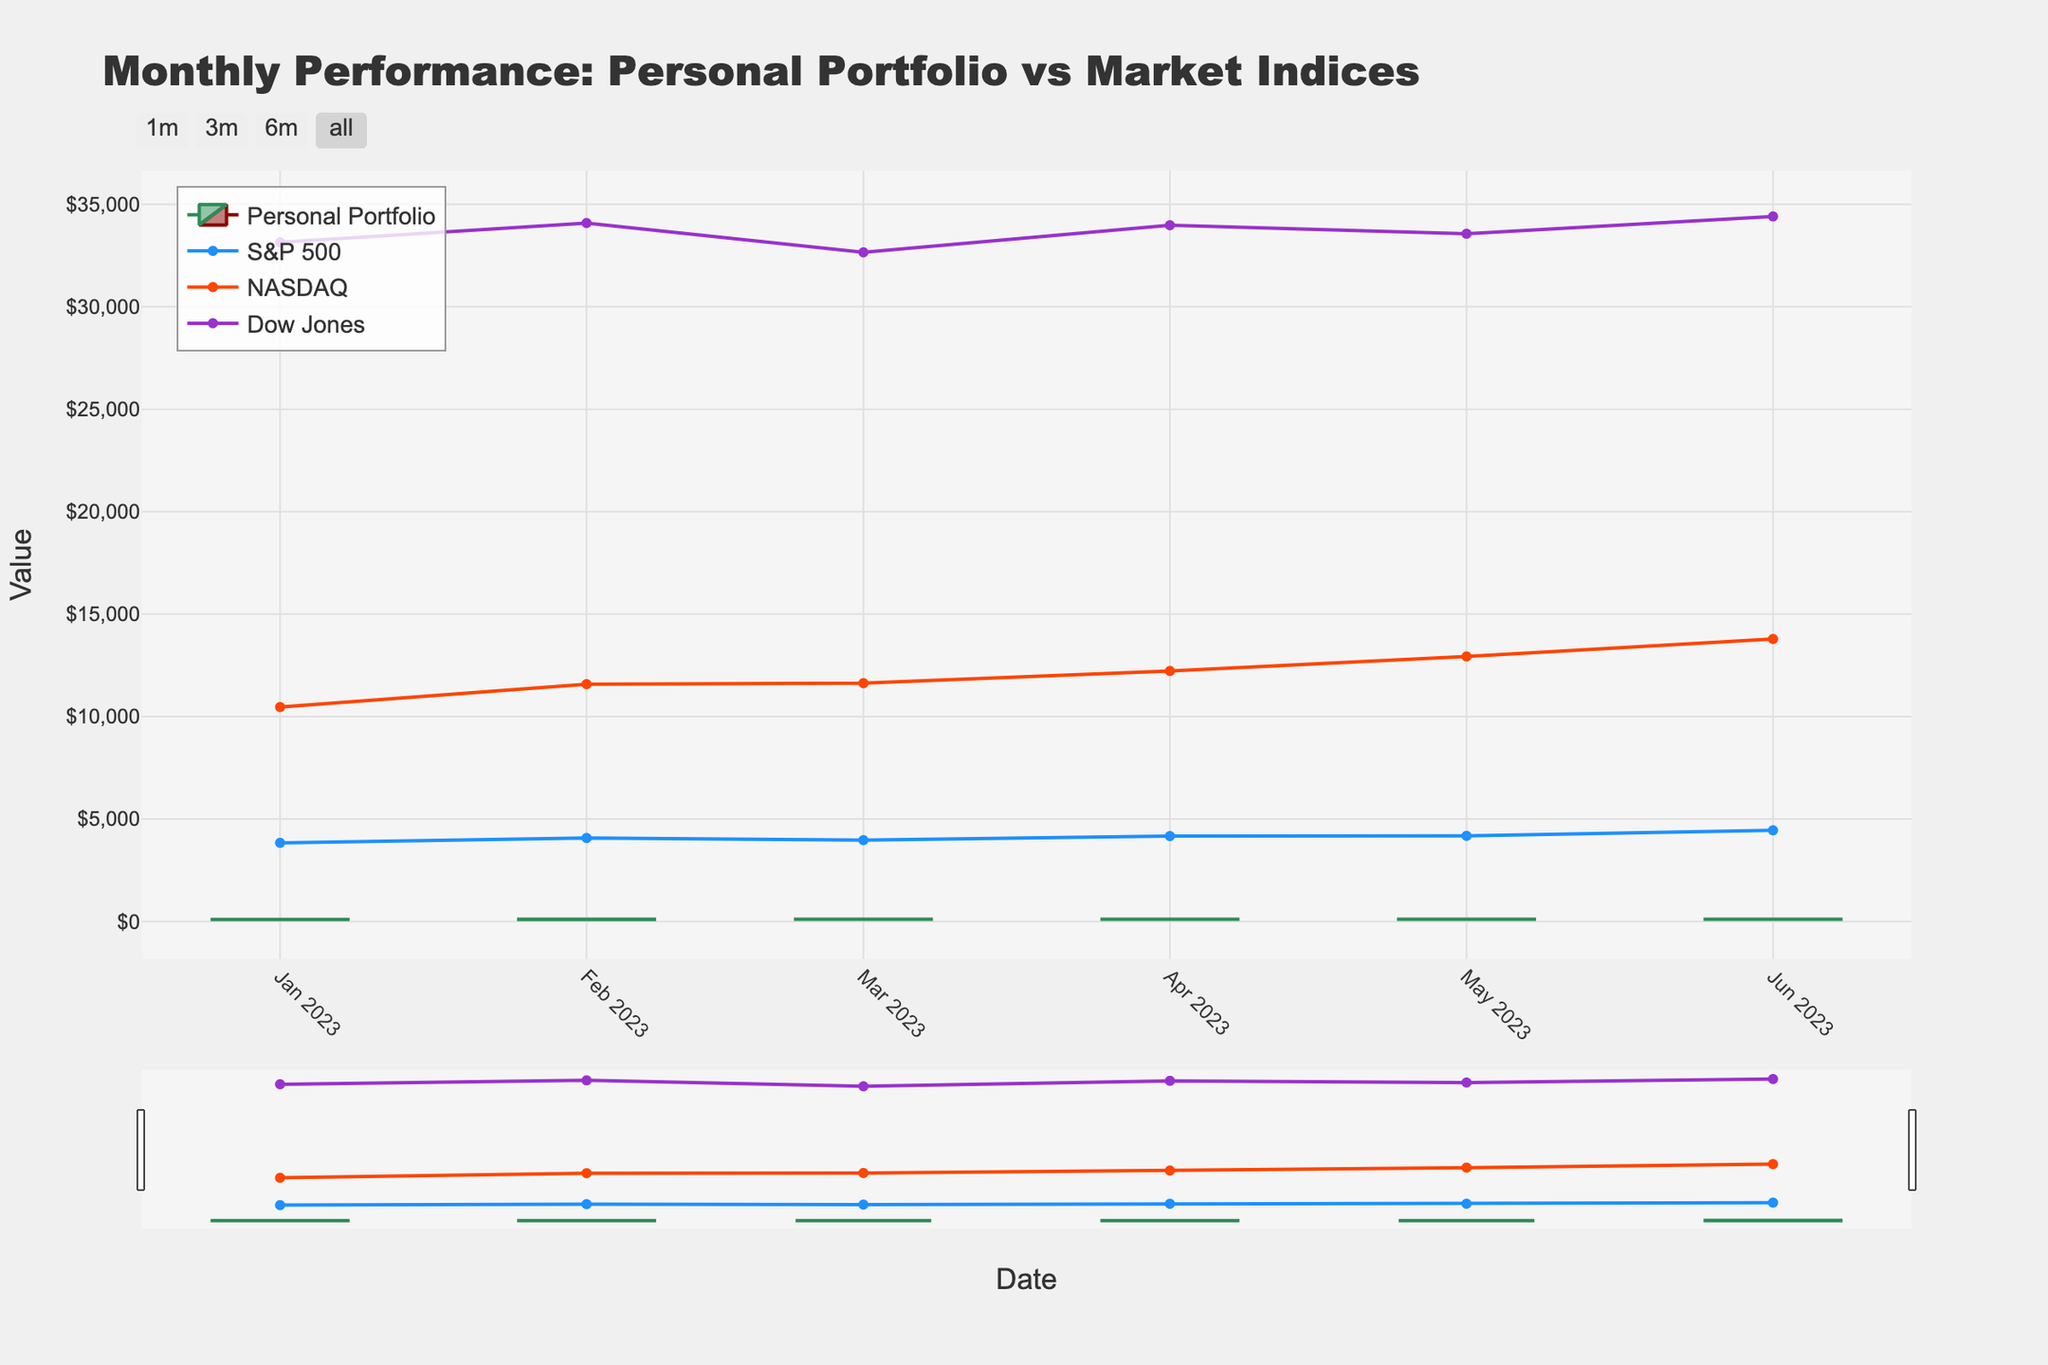What is the title of the figure? The title is located at the top of the figure and clearly states the overall subject of the chart.
Answer: Monthly Performance: Personal Portfolio vs Market Indices How many data points are there for the Personal Portfolio? Each monthly data point corresponds to a row in the data provided. By counting the rows, we see one for each month from January to June, which means there are 6 data points.
Answer: 6 Which month had the highest closing value for the Personal Portfolio? To find the highest closing value, look for the month where the 'Close' value of the Personal Portfolio is the greatest. By comparing these values, June has the highest closing value at 113.90.
Answer: June How does the closing value of the Personal Portfolio in April compare to that of the S&P 500 in the same month? Check the 'Close' value of the Personal Portfolio in April (109.25) and compare it to the value of S&P 500 for the same month (4169.48). The value of S&P 500 is higher than the Personal Portfolio.
Answer: S&P 500 is higher Which index showed the greatest increase from the beginning to the end of the period? Calculate the difference between the starting and ending values for each index: 
S&P 500: 4450.38 - 3839.50 = 610.88 
NASDAQ: 13787.92 - 10466.48 = 3321.44 
Dow Jones: 34407.60 - 33147.25 = 1260.35 
NASDAQ has the greatest increase.
Answer: NASDAQ In which month did the Personal Portfolio's opening value see the biggest increase compared to the previous month? Determine the difference between the 'Open' values of consecutive months:
Feb-Jan: 103.75 - 100.00 = 3.75
Mar-Feb: 106.50 - 103.75 = 2.75
Apr-Mar: 107.80 - 106.50 = 1.30
May-Apr: 109.25 - 107.80 = 1.45
Jun-May: 111.60 - 109.25 = 2.35
The biggest increase is observed from January to February.
Answer: February What is the overall trend of the Personal Portfolio's closing values from January to June? Examine the closing values across the months (103.75, 106.50, 107.80, 109.25, 111.60, 113.90). The values are increasing, indicating an upward trend.
Answer: Upward trend By the end of June, how does the Personal Portfolio's closing value compare to the Dow Jones? Check the closing value of the Personal Portfolio in June (113.90) and compare it with the value of Dow Jones (34407.60). The Dow Jones value is significantly higher.
Answer: Dow Jones is higher Which month experienced the highest volatility for the Personal Portfolio based on the difference between the high and low values? Calculate the difference between the 'High' and 'Low' values for each month:
Jan: 105.20 - 98.50 = 6.70
Feb: 108.30 - 101.80 = 6.50
Mar: 110.75 - 104.20 = 6.55
Apr: 112.40 - 105.60 = 6.80
May: 114.80 - 107.90 = 6.90
Jun: 116.30 - 109.75 = 6.55
May experienced the highest volatility with a difference of 6.90.
Answer: May 